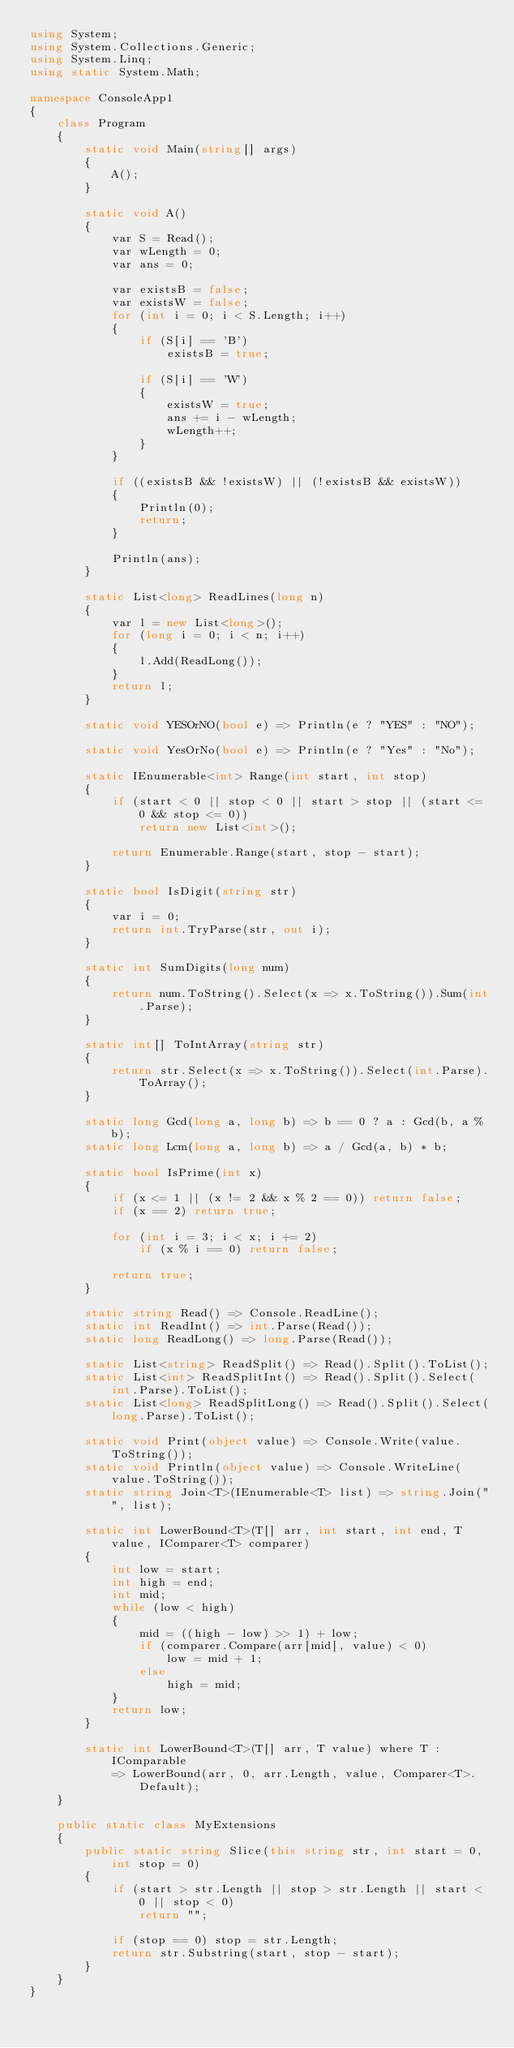Convert code to text. <code><loc_0><loc_0><loc_500><loc_500><_C#_>using System;
using System.Collections.Generic;
using System.Linq;
using static System.Math;

namespace ConsoleApp1
{
    class Program
    {
        static void Main(string[] args)
        {
            A();
        }

        static void A()
        {
            var S = Read();
            var wLength = 0;
            var ans = 0;

            var existsB = false;
            var existsW = false;
            for (int i = 0; i < S.Length; i++)
            {
                if (S[i] == 'B')
                    existsB = true;

                if (S[i] == 'W')
                {
                    existsW = true;
                    ans += i - wLength;
                    wLength++;
                }
            }

            if ((existsB && !existsW) || (!existsB && existsW))
            {
                Println(0);
                return;
            }

            Println(ans);
        }

        static List<long> ReadLines(long n)
        {
            var l = new List<long>();
            for (long i = 0; i < n; i++)
            {
                l.Add(ReadLong());
            }
            return l;
        }

        static void YESOrNO(bool e) => Println(e ? "YES" : "NO");

        static void YesOrNo(bool e) => Println(e ? "Yes" : "No");

        static IEnumerable<int> Range(int start, int stop)
        {
            if (start < 0 || stop < 0 || start > stop || (start <= 0 && stop <= 0))
                return new List<int>();

            return Enumerable.Range(start, stop - start);
        }

        static bool IsDigit(string str)
        {
            var i = 0;
            return int.TryParse(str, out i);
        }

        static int SumDigits(long num)
        {
            return num.ToString().Select(x => x.ToString()).Sum(int.Parse);
        }

        static int[] ToIntArray(string str)
        {
            return str.Select(x => x.ToString()).Select(int.Parse).ToArray();
        }

        static long Gcd(long a, long b) => b == 0 ? a : Gcd(b, a % b);
        static long Lcm(long a, long b) => a / Gcd(a, b) * b;

        static bool IsPrime(int x)
        {
            if (x <= 1 || (x != 2 && x % 2 == 0)) return false;
            if (x == 2) return true;

            for (int i = 3; i < x; i += 2)
                if (x % i == 0) return false;

            return true;
        }

        static string Read() => Console.ReadLine();
        static int ReadInt() => int.Parse(Read());
        static long ReadLong() => long.Parse(Read());

        static List<string> ReadSplit() => Read().Split().ToList();
        static List<int> ReadSplitInt() => Read().Split().Select(int.Parse).ToList();
        static List<long> ReadSplitLong() => Read().Split().Select(long.Parse).ToList();

        static void Print(object value) => Console.Write(value.ToString());
        static void Println(object value) => Console.WriteLine(value.ToString());
        static string Join<T>(IEnumerable<T> list) => string.Join("", list);

        static int LowerBound<T>(T[] arr, int start, int end, T value, IComparer<T> comparer)
        {
            int low = start;
            int high = end;
            int mid;
            while (low < high)
            {
                mid = ((high - low) >> 1) + low;
                if (comparer.Compare(arr[mid], value) < 0)
                    low = mid + 1;
                else
                    high = mid;
            }
            return low;
        }

        static int LowerBound<T>(T[] arr, T value) where T : IComparable 
            => LowerBound(arr, 0, arr.Length, value, Comparer<T>.Default);
    }

    public static class MyExtensions
    {
        public static string Slice(this string str, int start = 0, int stop = 0)
        {
            if (start > str.Length || stop > str.Length || start < 0 || stop < 0)
                return "";

            if (stop == 0) stop = str.Length;
            return str.Substring(start, stop - start);
        }
    }
}

</code> 